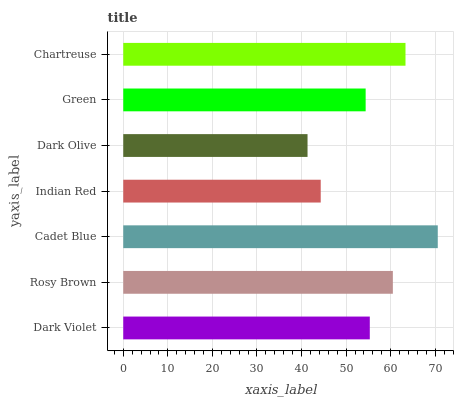Is Dark Olive the minimum?
Answer yes or no. Yes. Is Cadet Blue the maximum?
Answer yes or no. Yes. Is Rosy Brown the minimum?
Answer yes or no. No. Is Rosy Brown the maximum?
Answer yes or no. No. Is Rosy Brown greater than Dark Violet?
Answer yes or no. Yes. Is Dark Violet less than Rosy Brown?
Answer yes or no. Yes. Is Dark Violet greater than Rosy Brown?
Answer yes or no. No. Is Rosy Brown less than Dark Violet?
Answer yes or no. No. Is Dark Violet the high median?
Answer yes or no. Yes. Is Dark Violet the low median?
Answer yes or no. Yes. Is Indian Red the high median?
Answer yes or no. No. Is Cadet Blue the low median?
Answer yes or no. No. 